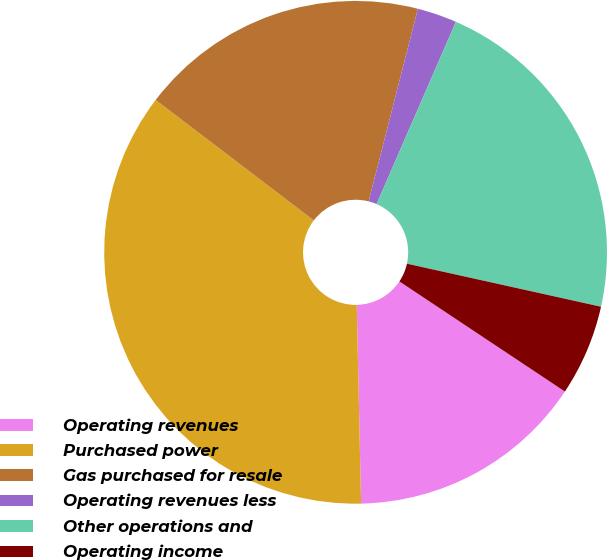<chart> <loc_0><loc_0><loc_500><loc_500><pie_chart><fcel>Operating revenues<fcel>Purchased power<fcel>Gas purchased for resale<fcel>Operating revenues less<fcel>Other operations and<fcel>Operating income<nl><fcel>15.31%<fcel>35.71%<fcel>18.62%<fcel>2.55%<fcel>21.94%<fcel>5.87%<nl></chart> 